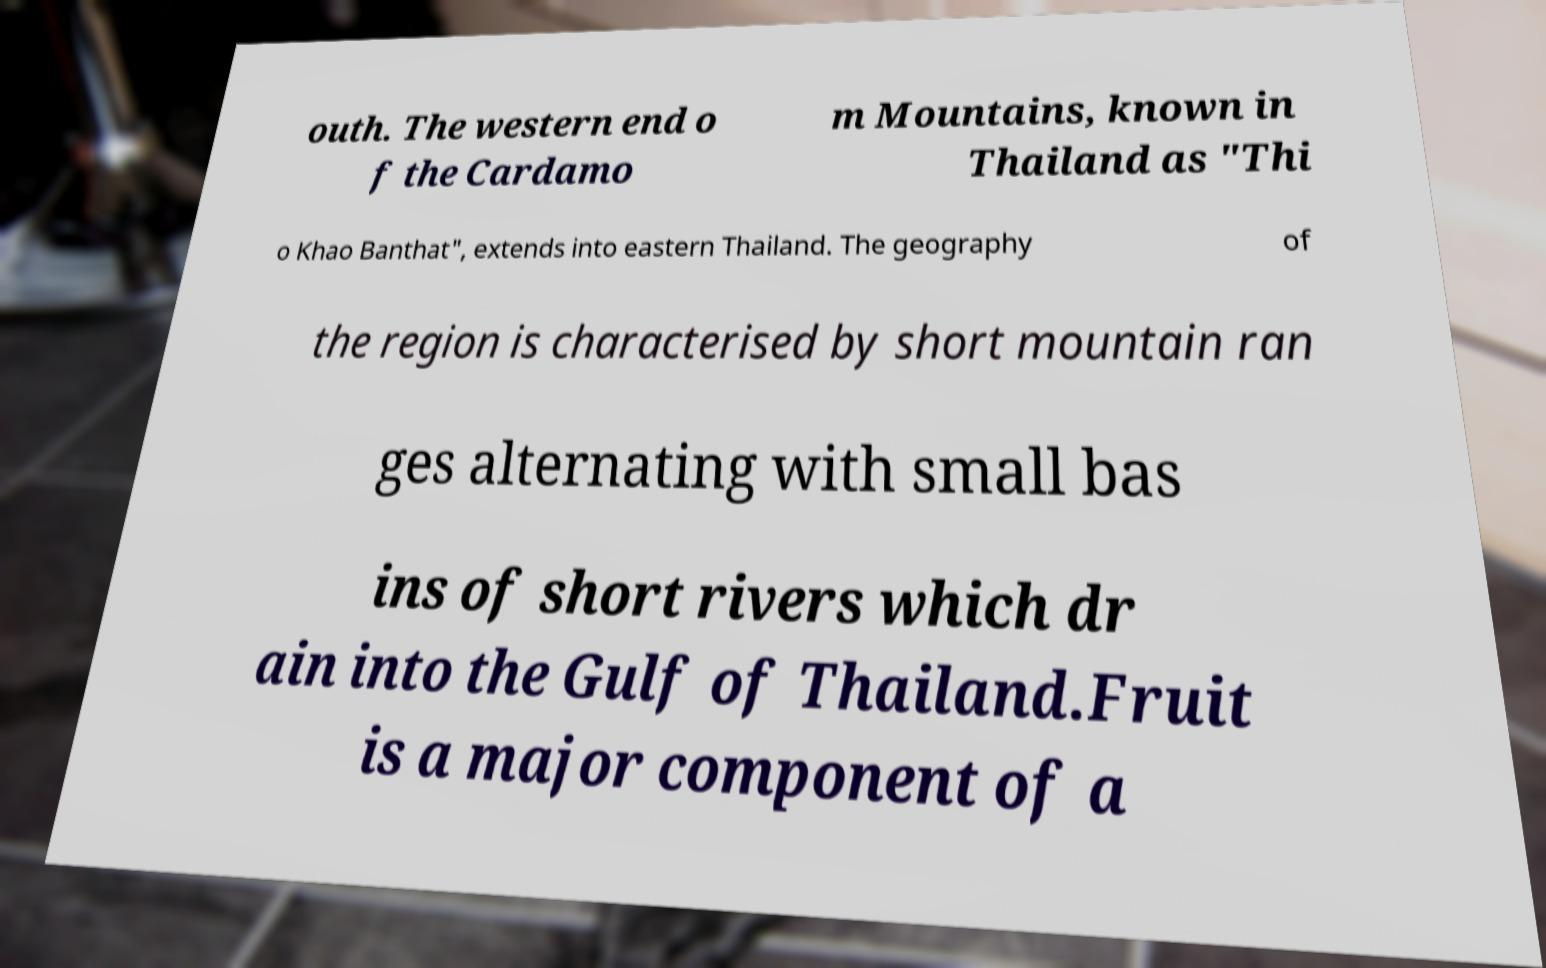Please identify and transcribe the text found in this image. outh. The western end o f the Cardamo m Mountains, known in Thailand as "Thi o Khao Banthat", extends into eastern Thailand. The geography of the region is characterised by short mountain ran ges alternating with small bas ins of short rivers which dr ain into the Gulf of Thailand.Fruit is a major component of a 